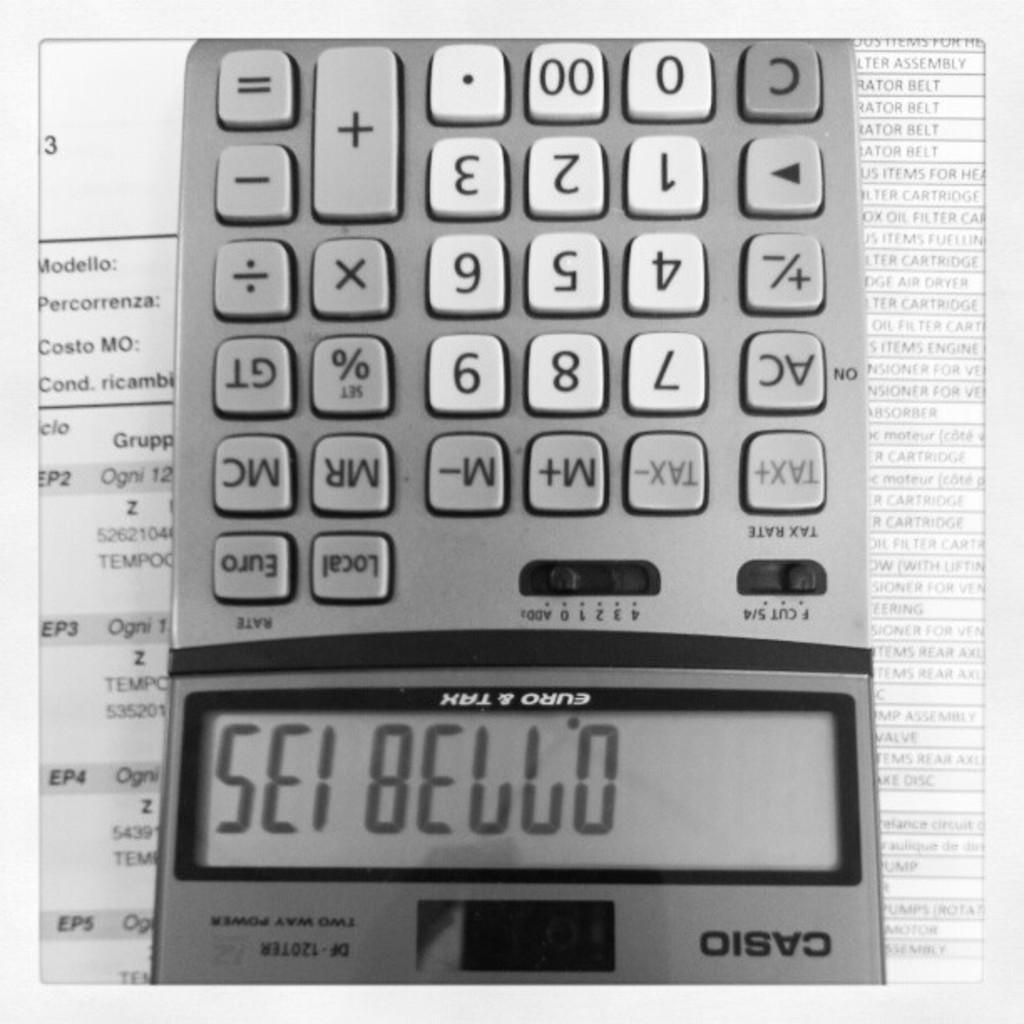<image>
Create a compact narrative representing the image presented. a casio calculator upside down that says 'sei bello' 